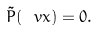<formula> <loc_0><loc_0><loc_500><loc_500>\tilde { P } ( \ v x ) = 0 .</formula> 